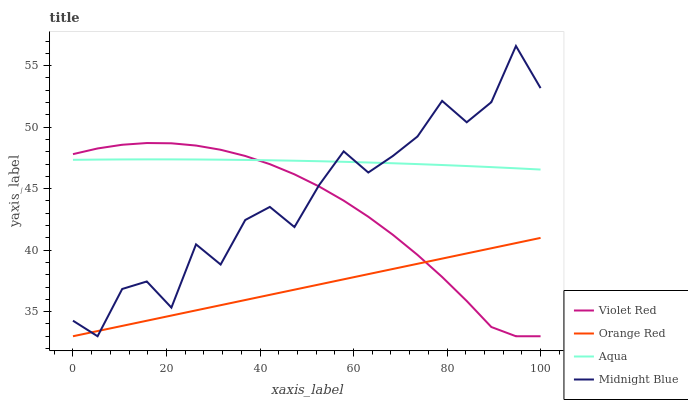Does Orange Red have the minimum area under the curve?
Answer yes or no. Yes. Does Aqua have the maximum area under the curve?
Answer yes or no. Yes. Does Aqua have the minimum area under the curve?
Answer yes or no. No. Does Orange Red have the maximum area under the curve?
Answer yes or no. No. Is Orange Red the smoothest?
Answer yes or no. Yes. Is Midnight Blue the roughest?
Answer yes or no. Yes. Is Aqua the smoothest?
Answer yes or no. No. Is Aqua the roughest?
Answer yes or no. No. Does Violet Red have the lowest value?
Answer yes or no. Yes. Does Aqua have the lowest value?
Answer yes or no. No. Does Midnight Blue have the highest value?
Answer yes or no. Yes. Does Aqua have the highest value?
Answer yes or no. No. Is Orange Red less than Aqua?
Answer yes or no. Yes. Is Aqua greater than Orange Red?
Answer yes or no. Yes. Does Orange Red intersect Violet Red?
Answer yes or no. Yes. Is Orange Red less than Violet Red?
Answer yes or no. No. Is Orange Red greater than Violet Red?
Answer yes or no. No. Does Orange Red intersect Aqua?
Answer yes or no. No. 